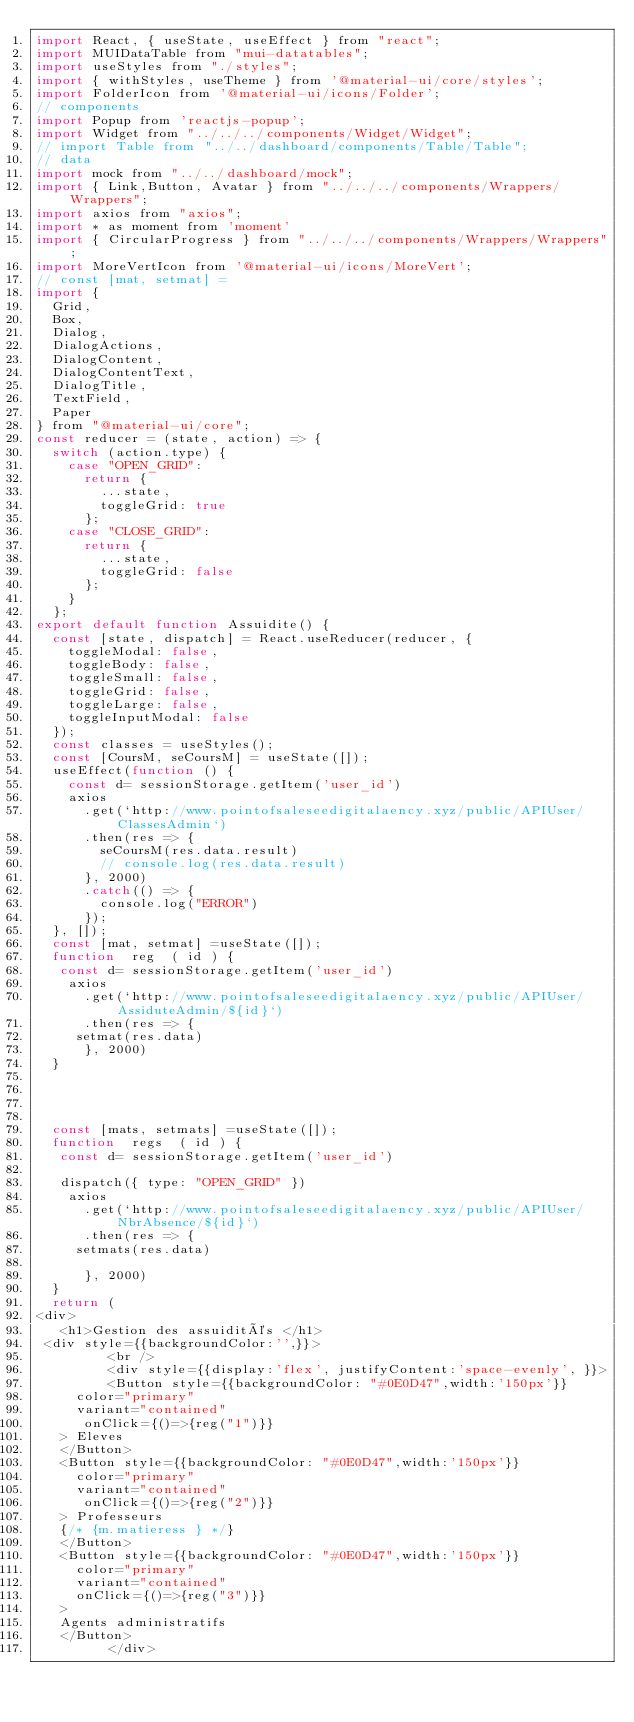Convert code to text. <code><loc_0><loc_0><loc_500><loc_500><_JavaScript_>import React, { useState, useEffect } from "react"; 
import MUIDataTable from "mui-datatables";
import useStyles from "./styles";
import { withStyles, useTheme } from '@material-ui/core/styles';
import FolderIcon from '@material-ui/icons/Folder';
// components
import Popup from 'reactjs-popup';
import Widget from "../../../components/Widget/Widget";
// import Table from "../../dashboard/components/Table/Table";
// data
import mock from "../../dashboard/mock";
import { Link,Button, Avatar } from "../../../components/Wrappers/Wrappers";
import axios from "axios";
import * as moment from 'moment'
import { CircularProgress } from "../../../components/Wrappers/Wrappers";
import MoreVertIcon from '@material-ui/icons/MoreVert';
// const [mat, setmat] =  
import {
  Grid,
  Box,
  Dialog,
  DialogActions,
  DialogContent,
  DialogContentText,
  DialogTitle,
  TextField,
  Paper
} from "@material-ui/core";
const reducer = (state, action) => {
  switch (action.type) {
    case "OPEN_GRID":
      return {
        ...state,
        toggleGrid: true
      };
    case "CLOSE_GRID":
      return {
        ...state,
        toggleGrid: false
      };
    }
  };
export default function Assuidite() {
  const [state, dispatch] = React.useReducer(reducer, {
    toggleModal: false,
    toggleBody: false,
    toggleSmall: false,
    toggleGrid: false,
    toggleLarge: false,
    toggleInputModal: false
  });
  const classes = useStyles();
  const [CoursM, seCoursM] = useState([]);
  useEffect(function () {
    const d= sessionStorage.getItem('user_id')
    axios
      .get(`http://www.pointofsaleseedigitalaency.xyz/public/APIUser/ClassesAdmin`)
      .then(res => {
        seCoursM(res.data.result)
        // console.log(res.data.result)
      }, 2000)
      .catch(() => {
        console.log("ERROR")
      });
  }, []);
  const [mat, setmat] =useState([]);
  function  reg  ( id ) {
   const d= sessionStorage.getItem('user_id')
    axios
      .get(`http://www.pointofsaleseedigitalaency.xyz/public/APIUser/AssiduteAdmin/${id}`)
      .then(res => {
     setmat(res.data)
      }, 2000)
  } 




  const [mats, setmats] =useState([]);
  function  regs  ( id ) {
   const d= sessionStorage.getItem('user_id')

   dispatch({ type: "OPEN_GRID" })
    axios
      .get(`http://www.pointofsaleseedigitalaency.xyz/public/APIUser/NbrAbsence/${id}`)
      .then(res => {
     setmats(res.data)
    
      }, 2000)
  } 
  return (
<div>
   <h1>Gestion des assuidités </h1>
 <div style={{backgroundColor:'',}}>
         <br />
         <div style={{display:'flex', justifyContent:'space-evenly', }}>
         <Button style={{backgroundColor: "#0E0D47",width:'150px'}}
     color="primary"
     variant="contained"
      onClick={()=>{reg("1")}} 
   > Eleves
   </Button>
   <Button style={{backgroundColor: "#0E0D47",width:'150px'}}
     color="primary"
     variant="contained"
      onClick={()=>{reg("2")}} 
   > Professeurs
   {/* {m.matieress } */}
   </Button>
   <Button style={{backgroundColor: "#0E0D47",width:'150px'}}
     color="primary"
     variant="contained"
     onClick={()=>{reg("3")}} 
   > 
   Agents administratifs
   </Button>
         </div></code> 